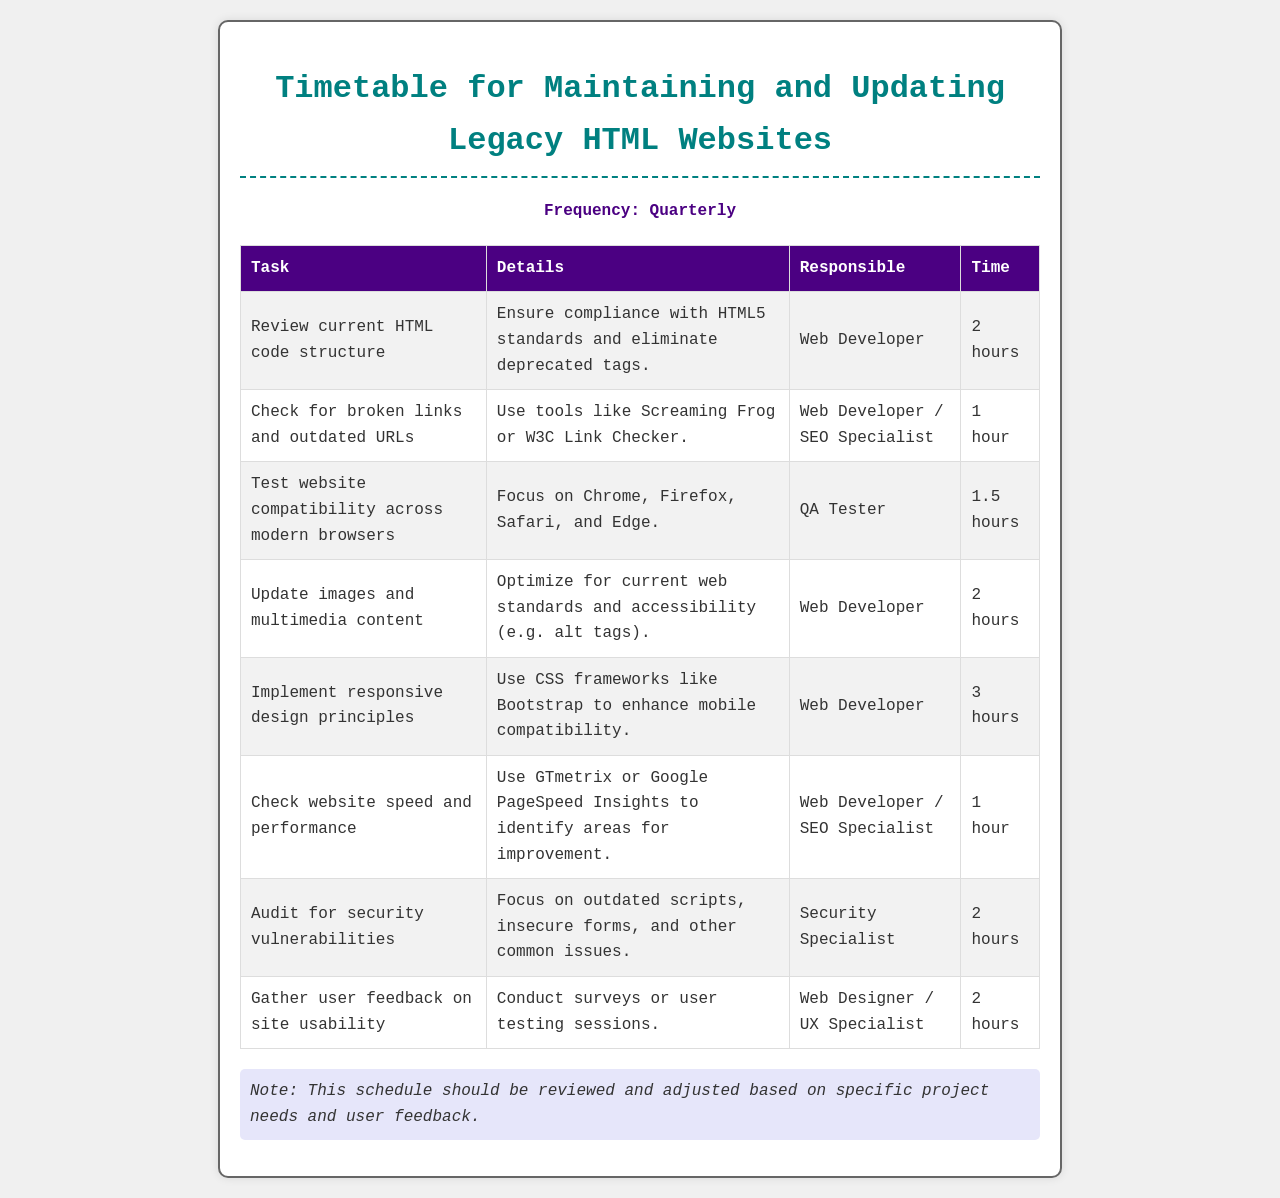What is the frequency of the maintenance tasks? The frequency mentioned in the document indicates how often the tasks should be performed, which is quarterly.
Answer: Quarterly Who is responsible for checking broken links? This identifies the individuals responsible for this specific task as mentioned in the document.
Answer: Web Developer / SEO Specialist How long is allocated for testing website compatibility? The document specifies the amount of time dedicated to this task, which was listed in hours.
Answer: 1.5 hours What task involves optimizing images and multimedia content? This question asks for the specific task that deals with media updates, as defined in the document.
Answer: Update images and multimedia content Which tool is recommended for checking website speed? This question looks for the tool that is suggested in the document for assessing website performance.
Answer: GTmetrix or Google PageSpeed Insights What is the total time allocated for implementing responsive design? This requires summing the time specified in the document for this specific task.
Answer: 3 hours Which role is responsible for auditing security vulnerabilities? This identifies the individual or title assigned to perform this task.
Answer: Security Specialist What is the purpose of gathering user feedback on site usability? This relates to why this task is important as stated in the document's details section.
Answer: Conduct surveys or user testing sessions 